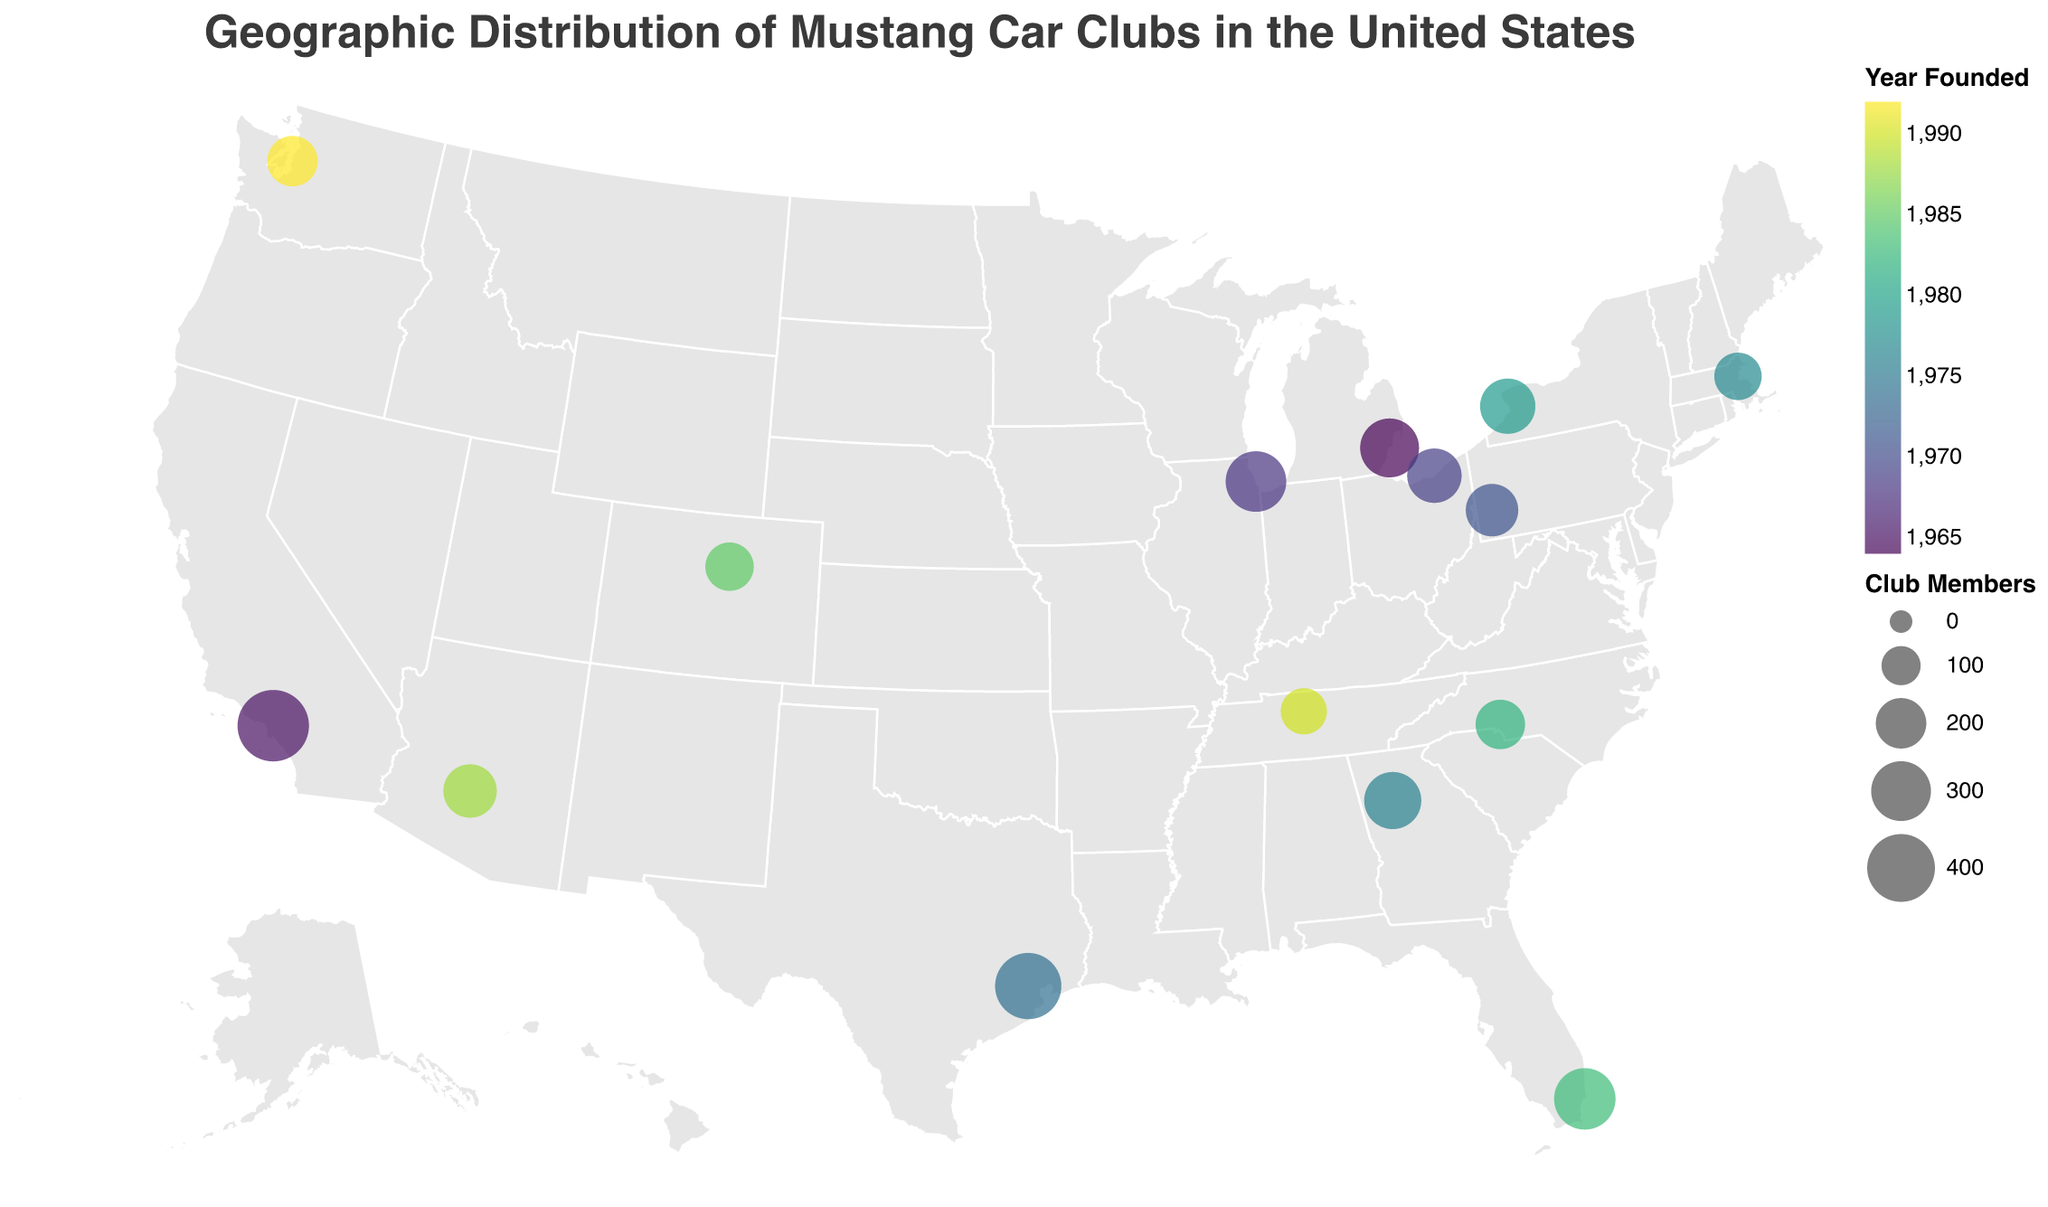How many Mustang car clubs are displayed on the map? Count the number of circles representing the clubs on the geographic plot. Each circle represents one club.
Answer: 15 Which car club has the most members and in which city is it located? Look for the largest circle on the map and check its tooltip data or the size encoding scale. It indicates the club with the highest membership count.
Answer: SoCal Mustang Owners Club in Los Angeles Which car club was founded earliest, and how many members does it have? Identify the club with the earliest year in the year founded color scale or tooltips. Check the membership count in the same data point.
Answer: Motor City Mustangs in Detroit with 290 members What is the average number of members in Mustang car clubs in the eastern United States (east of the Mississippi River)? Identify the relevant cities on the eastern side of the map, sum their membership numbers, and divide by the number of these clubs (Buffalo, Miami, Pittsburgh, Cleveland, Charlotte, Boston).
Answer: 215 Which state has the highest number of Mustang car clubs represented? Count the distinct states from the map’s tooltips or data points. The state mentioned most frequently has the highest number.
Answer: California Which club in Texas has the most members, and how many members are there? Identify the club in Texas by its tooltip and observe the size of the circle or check the data in the tooltip.
Answer: Lone Star Mustang Club in Houston with 380 members Which Mustang car club has the smallest number of members, and where is it located? Find the smallest circle on the plot and check its tooltip data for membership count and location.
Answer: Music City Mustang Club in Nashville with 160 members Are there more Mustang car clubs founded before or after 1980? Count the clubs with founding years before and after 1980 using the color scale or tooltip data. Compare the two counts.
Answer: Before 1980 What is the total number of members across all Mustang car clubs on the map? Sum the membership numbers of all the clubs from the plot’s data points.
Answer: 4160 How is the distribution of Mustang car clubs spread geographically across the United States? Observe the geographic plot and describe the concentration and spread of circles across different regions of the map, taking note of areas with higher densities of clubs.
Answer: Widely distributed with higher concentrations in California and the eastern US 